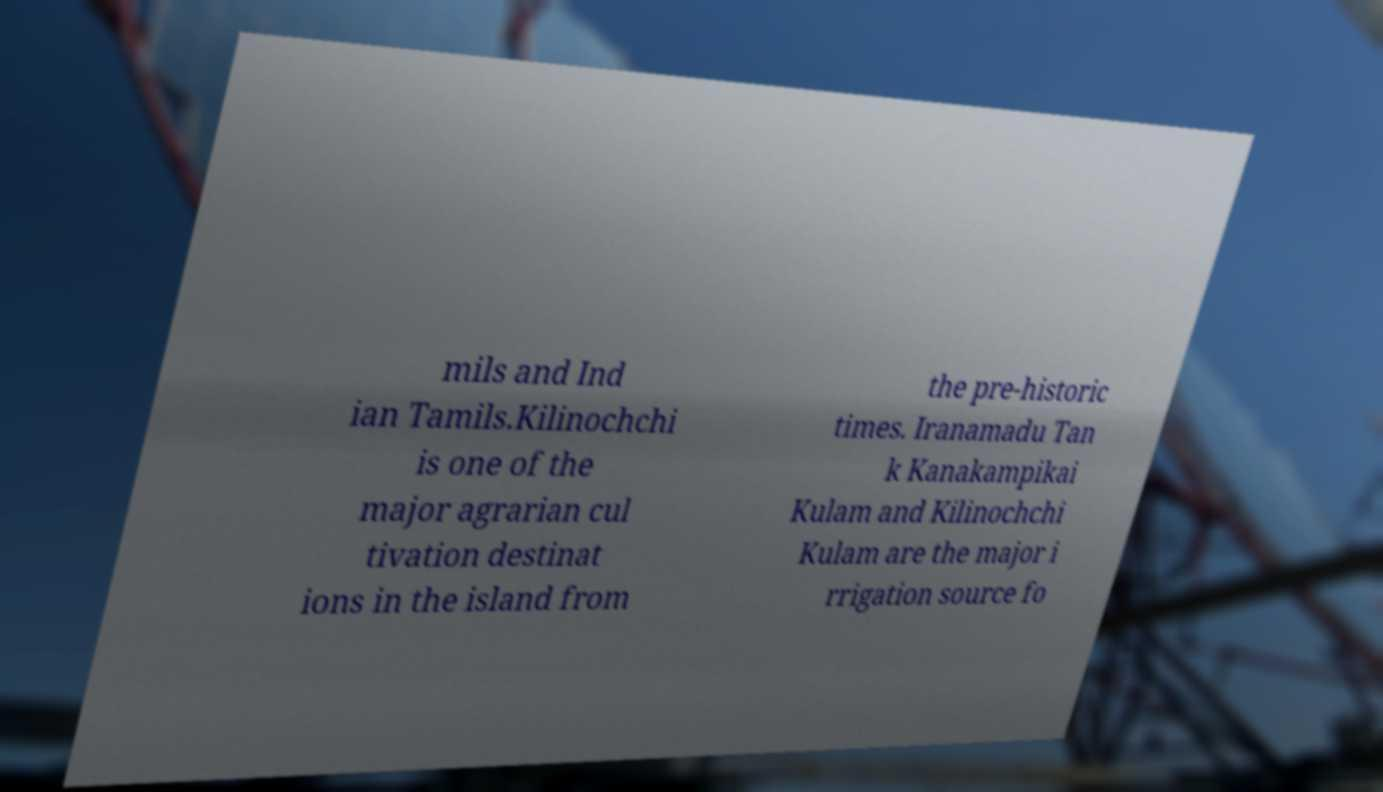Can you read and provide the text displayed in the image?This photo seems to have some interesting text. Can you extract and type it out for me? mils and Ind ian Tamils.Kilinochchi is one of the major agrarian cul tivation destinat ions in the island from the pre-historic times. Iranamadu Tan k Kanakampikai Kulam and Kilinochchi Kulam are the major i rrigation source fo 